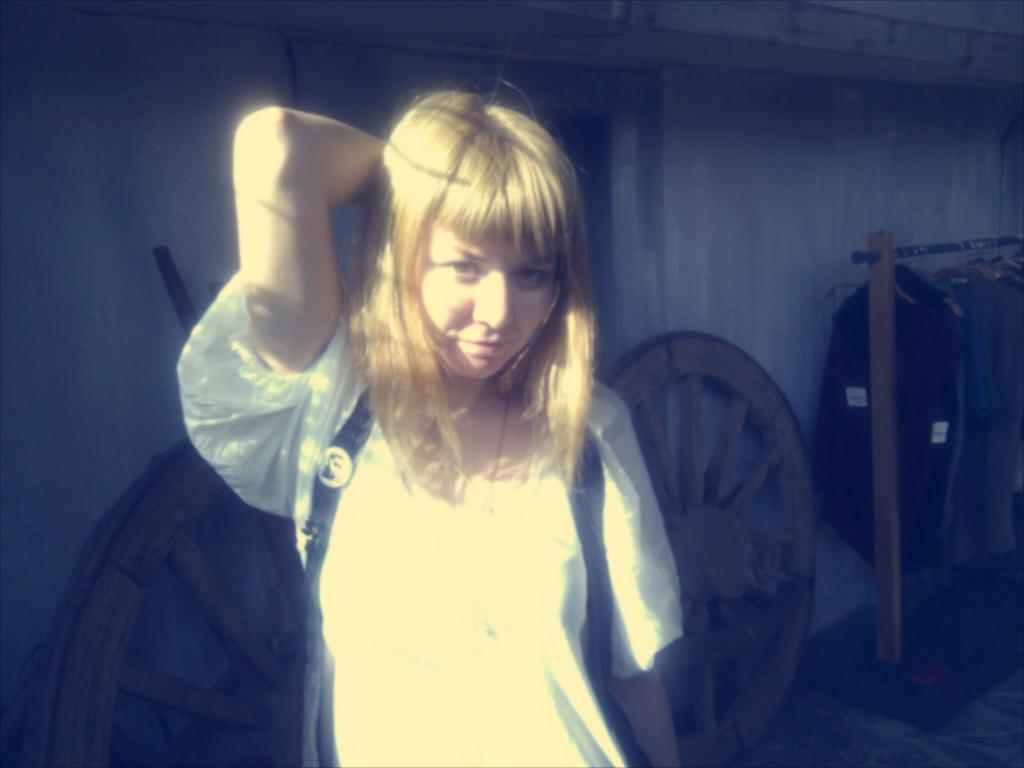Please provide a concise description of this image. In this image we can see a lady. In the back there are wheels. Also there is a stand. On the stand there are dresses hanged on hangers. In the back there is a wall. 